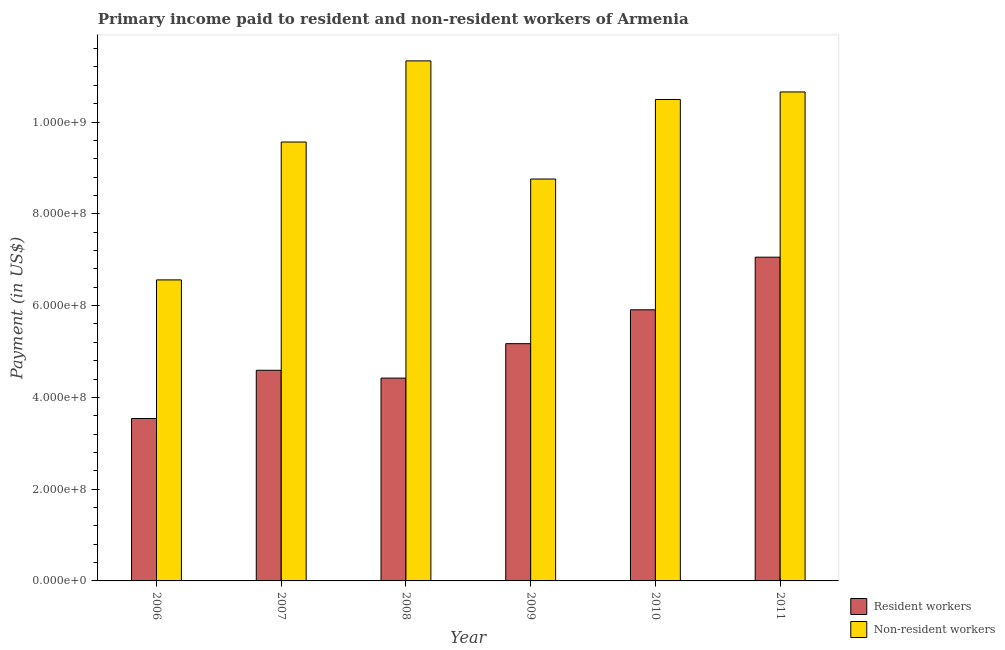How many different coloured bars are there?
Ensure brevity in your answer.  2. Are the number of bars on each tick of the X-axis equal?
Give a very brief answer. Yes. How many bars are there on the 4th tick from the right?
Offer a very short reply. 2. What is the label of the 3rd group of bars from the left?
Offer a very short reply. 2008. In how many cases, is the number of bars for a given year not equal to the number of legend labels?
Provide a succinct answer. 0. What is the payment made to resident workers in 2009?
Your response must be concise. 5.17e+08. Across all years, what is the maximum payment made to non-resident workers?
Your answer should be compact. 1.13e+09. Across all years, what is the minimum payment made to non-resident workers?
Offer a very short reply. 6.56e+08. What is the total payment made to non-resident workers in the graph?
Ensure brevity in your answer.  5.74e+09. What is the difference between the payment made to non-resident workers in 2006 and that in 2009?
Provide a short and direct response. -2.20e+08. What is the difference between the payment made to non-resident workers in 2008 and the payment made to resident workers in 2007?
Your answer should be compact. 1.77e+08. What is the average payment made to non-resident workers per year?
Your answer should be compact. 9.56e+08. In the year 2010, what is the difference between the payment made to resident workers and payment made to non-resident workers?
Make the answer very short. 0. In how many years, is the payment made to non-resident workers greater than 760000000 US$?
Keep it short and to the point. 5. What is the ratio of the payment made to resident workers in 2010 to that in 2011?
Your answer should be compact. 0.84. Is the payment made to resident workers in 2007 less than that in 2009?
Keep it short and to the point. Yes. What is the difference between the highest and the second highest payment made to non-resident workers?
Offer a terse response. 6.77e+07. What is the difference between the highest and the lowest payment made to non-resident workers?
Make the answer very short. 4.77e+08. What does the 2nd bar from the left in 2008 represents?
Keep it short and to the point. Non-resident workers. What does the 1st bar from the right in 2006 represents?
Offer a terse response. Non-resident workers. How many bars are there?
Give a very brief answer. 12. Are all the bars in the graph horizontal?
Offer a terse response. No. How many years are there in the graph?
Offer a terse response. 6. What is the difference between two consecutive major ticks on the Y-axis?
Offer a terse response. 2.00e+08. Are the values on the major ticks of Y-axis written in scientific E-notation?
Provide a succinct answer. Yes. Does the graph contain any zero values?
Your response must be concise. No. Where does the legend appear in the graph?
Your response must be concise. Bottom right. How many legend labels are there?
Keep it short and to the point. 2. How are the legend labels stacked?
Your answer should be very brief. Vertical. What is the title of the graph?
Your response must be concise. Primary income paid to resident and non-resident workers of Armenia. Does "UN agencies" appear as one of the legend labels in the graph?
Offer a terse response. No. What is the label or title of the X-axis?
Offer a terse response. Year. What is the label or title of the Y-axis?
Give a very brief answer. Payment (in US$). What is the Payment (in US$) in Resident workers in 2006?
Offer a very short reply. 3.54e+08. What is the Payment (in US$) in Non-resident workers in 2006?
Offer a terse response. 6.56e+08. What is the Payment (in US$) in Resident workers in 2007?
Keep it short and to the point. 4.59e+08. What is the Payment (in US$) in Non-resident workers in 2007?
Give a very brief answer. 9.56e+08. What is the Payment (in US$) of Resident workers in 2008?
Keep it short and to the point. 4.42e+08. What is the Payment (in US$) of Non-resident workers in 2008?
Make the answer very short. 1.13e+09. What is the Payment (in US$) of Resident workers in 2009?
Offer a terse response. 5.17e+08. What is the Payment (in US$) of Non-resident workers in 2009?
Ensure brevity in your answer.  8.76e+08. What is the Payment (in US$) in Resident workers in 2010?
Keep it short and to the point. 5.91e+08. What is the Payment (in US$) in Non-resident workers in 2010?
Provide a succinct answer. 1.05e+09. What is the Payment (in US$) of Resident workers in 2011?
Offer a very short reply. 7.05e+08. What is the Payment (in US$) of Non-resident workers in 2011?
Your answer should be very brief. 1.07e+09. Across all years, what is the maximum Payment (in US$) of Resident workers?
Your answer should be very brief. 7.05e+08. Across all years, what is the maximum Payment (in US$) in Non-resident workers?
Make the answer very short. 1.13e+09. Across all years, what is the minimum Payment (in US$) of Resident workers?
Your response must be concise. 3.54e+08. Across all years, what is the minimum Payment (in US$) in Non-resident workers?
Your response must be concise. 6.56e+08. What is the total Payment (in US$) in Resident workers in the graph?
Provide a short and direct response. 3.07e+09. What is the total Payment (in US$) of Non-resident workers in the graph?
Ensure brevity in your answer.  5.74e+09. What is the difference between the Payment (in US$) in Resident workers in 2006 and that in 2007?
Your response must be concise. -1.05e+08. What is the difference between the Payment (in US$) in Non-resident workers in 2006 and that in 2007?
Keep it short and to the point. -3.00e+08. What is the difference between the Payment (in US$) in Resident workers in 2006 and that in 2008?
Offer a terse response. -8.80e+07. What is the difference between the Payment (in US$) in Non-resident workers in 2006 and that in 2008?
Keep it short and to the point. -4.77e+08. What is the difference between the Payment (in US$) of Resident workers in 2006 and that in 2009?
Provide a short and direct response. -1.63e+08. What is the difference between the Payment (in US$) of Non-resident workers in 2006 and that in 2009?
Make the answer very short. -2.20e+08. What is the difference between the Payment (in US$) of Resident workers in 2006 and that in 2010?
Keep it short and to the point. -2.37e+08. What is the difference between the Payment (in US$) of Non-resident workers in 2006 and that in 2010?
Give a very brief answer. -3.93e+08. What is the difference between the Payment (in US$) of Resident workers in 2006 and that in 2011?
Give a very brief answer. -3.52e+08. What is the difference between the Payment (in US$) of Non-resident workers in 2006 and that in 2011?
Give a very brief answer. -4.10e+08. What is the difference between the Payment (in US$) in Resident workers in 2007 and that in 2008?
Keep it short and to the point. 1.71e+07. What is the difference between the Payment (in US$) of Non-resident workers in 2007 and that in 2008?
Keep it short and to the point. -1.77e+08. What is the difference between the Payment (in US$) in Resident workers in 2007 and that in 2009?
Provide a succinct answer. -5.80e+07. What is the difference between the Payment (in US$) in Non-resident workers in 2007 and that in 2009?
Your answer should be very brief. 8.07e+07. What is the difference between the Payment (in US$) in Resident workers in 2007 and that in 2010?
Ensure brevity in your answer.  -1.32e+08. What is the difference between the Payment (in US$) in Non-resident workers in 2007 and that in 2010?
Offer a very short reply. -9.26e+07. What is the difference between the Payment (in US$) in Resident workers in 2007 and that in 2011?
Your answer should be compact. -2.46e+08. What is the difference between the Payment (in US$) of Non-resident workers in 2007 and that in 2011?
Keep it short and to the point. -1.09e+08. What is the difference between the Payment (in US$) of Resident workers in 2008 and that in 2009?
Provide a succinct answer. -7.50e+07. What is the difference between the Payment (in US$) in Non-resident workers in 2008 and that in 2009?
Offer a very short reply. 2.57e+08. What is the difference between the Payment (in US$) of Resident workers in 2008 and that in 2010?
Your answer should be compact. -1.49e+08. What is the difference between the Payment (in US$) in Non-resident workers in 2008 and that in 2010?
Your response must be concise. 8.42e+07. What is the difference between the Payment (in US$) in Resident workers in 2008 and that in 2011?
Offer a very short reply. -2.63e+08. What is the difference between the Payment (in US$) in Non-resident workers in 2008 and that in 2011?
Provide a short and direct response. 6.77e+07. What is the difference between the Payment (in US$) of Resident workers in 2009 and that in 2010?
Ensure brevity in your answer.  -7.38e+07. What is the difference between the Payment (in US$) of Non-resident workers in 2009 and that in 2010?
Provide a short and direct response. -1.73e+08. What is the difference between the Payment (in US$) in Resident workers in 2009 and that in 2011?
Your answer should be very brief. -1.88e+08. What is the difference between the Payment (in US$) in Non-resident workers in 2009 and that in 2011?
Give a very brief answer. -1.90e+08. What is the difference between the Payment (in US$) of Resident workers in 2010 and that in 2011?
Your answer should be compact. -1.15e+08. What is the difference between the Payment (in US$) of Non-resident workers in 2010 and that in 2011?
Your answer should be compact. -1.65e+07. What is the difference between the Payment (in US$) of Resident workers in 2006 and the Payment (in US$) of Non-resident workers in 2007?
Keep it short and to the point. -6.03e+08. What is the difference between the Payment (in US$) of Resident workers in 2006 and the Payment (in US$) of Non-resident workers in 2008?
Give a very brief answer. -7.79e+08. What is the difference between the Payment (in US$) of Resident workers in 2006 and the Payment (in US$) of Non-resident workers in 2009?
Your answer should be compact. -5.22e+08. What is the difference between the Payment (in US$) of Resident workers in 2006 and the Payment (in US$) of Non-resident workers in 2010?
Offer a terse response. -6.95e+08. What is the difference between the Payment (in US$) of Resident workers in 2006 and the Payment (in US$) of Non-resident workers in 2011?
Keep it short and to the point. -7.12e+08. What is the difference between the Payment (in US$) in Resident workers in 2007 and the Payment (in US$) in Non-resident workers in 2008?
Offer a terse response. -6.74e+08. What is the difference between the Payment (in US$) in Resident workers in 2007 and the Payment (in US$) in Non-resident workers in 2009?
Give a very brief answer. -4.17e+08. What is the difference between the Payment (in US$) in Resident workers in 2007 and the Payment (in US$) in Non-resident workers in 2010?
Offer a terse response. -5.90e+08. What is the difference between the Payment (in US$) in Resident workers in 2007 and the Payment (in US$) in Non-resident workers in 2011?
Give a very brief answer. -6.07e+08. What is the difference between the Payment (in US$) of Resident workers in 2008 and the Payment (in US$) of Non-resident workers in 2009?
Offer a terse response. -4.34e+08. What is the difference between the Payment (in US$) of Resident workers in 2008 and the Payment (in US$) of Non-resident workers in 2010?
Offer a very short reply. -6.07e+08. What is the difference between the Payment (in US$) of Resident workers in 2008 and the Payment (in US$) of Non-resident workers in 2011?
Your response must be concise. -6.24e+08. What is the difference between the Payment (in US$) of Resident workers in 2009 and the Payment (in US$) of Non-resident workers in 2010?
Your answer should be very brief. -5.32e+08. What is the difference between the Payment (in US$) in Resident workers in 2009 and the Payment (in US$) in Non-resident workers in 2011?
Provide a succinct answer. -5.49e+08. What is the difference between the Payment (in US$) in Resident workers in 2010 and the Payment (in US$) in Non-resident workers in 2011?
Your answer should be compact. -4.75e+08. What is the average Payment (in US$) of Resident workers per year?
Provide a short and direct response. 5.11e+08. What is the average Payment (in US$) of Non-resident workers per year?
Your answer should be compact. 9.56e+08. In the year 2006, what is the difference between the Payment (in US$) in Resident workers and Payment (in US$) in Non-resident workers?
Ensure brevity in your answer.  -3.02e+08. In the year 2007, what is the difference between the Payment (in US$) of Resident workers and Payment (in US$) of Non-resident workers?
Ensure brevity in your answer.  -4.97e+08. In the year 2008, what is the difference between the Payment (in US$) in Resident workers and Payment (in US$) in Non-resident workers?
Your response must be concise. -6.91e+08. In the year 2009, what is the difference between the Payment (in US$) of Resident workers and Payment (in US$) of Non-resident workers?
Ensure brevity in your answer.  -3.59e+08. In the year 2010, what is the difference between the Payment (in US$) in Resident workers and Payment (in US$) in Non-resident workers?
Your answer should be very brief. -4.58e+08. In the year 2011, what is the difference between the Payment (in US$) in Resident workers and Payment (in US$) in Non-resident workers?
Your answer should be compact. -3.60e+08. What is the ratio of the Payment (in US$) in Resident workers in 2006 to that in 2007?
Offer a very short reply. 0.77. What is the ratio of the Payment (in US$) of Non-resident workers in 2006 to that in 2007?
Offer a terse response. 0.69. What is the ratio of the Payment (in US$) in Resident workers in 2006 to that in 2008?
Provide a succinct answer. 0.8. What is the ratio of the Payment (in US$) of Non-resident workers in 2006 to that in 2008?
Your answer should be very brief. 0.58. What is the ratio of the Payment (in US$) of Resident workers in 2006 to that in 2009?
Your answer should be very brief. 0.68. What is the ratio of the Payment (in US$) in Non-resident workers in 2006 to that in 2009?
Provide a succinct answer. 0.75. What is the ratio of the Payment (in US$) of Resident workers in 2006 to that in 2010?
Make the answer very short. 0.6. What is the ratio of the Payment (in US$) of Non-resident workers in 2006 to that in 2010?
Your response must be concise. 0.63. What is the ratio of the Payment (in US$) of Resident workers in 2006 to that in 2011?
Your response must be concise. 0.5. What is the ratio of the Payment (in US$) of Non-resident workers in 2006 to that in 2011?
Your answer should be compact. 0.62. What is the ratio of the Payment (in US$) of Resident workers in 2007 to that in 2008?
Provide a succinct answer. 1.04. What is the ratio of the Payment (in US$) of Non-resident workers in 2007 to that in 2008?
Ensure brevity in your answer.  0.84. What is the ratio of the Payment (in US$) of Resident workers in 2007 to that in 2009?
Offer a very short reply. 0.89. What is the ratio of the Payment (in US$) of Non-resident workers in 2007 to that in 2009?
Your answer should be very brief. 1.09. What is the ratio of the Payment (in US$) in Resident workers in 2007 to that in 2010?
Provide a succinct answer. 0.78. What is the ratio of the Payment (in US$) in Non-resident workers in 2007 to that in 2010?
Your answer should be compact. 0.91. What is the ratio of the Payment (in US$) of Resident workers in 2007 to that in 2011?
Make the answer very short. 0.65. What is the ratio of the Payment (in US$) of Non-resident workers in 2007 to that in 2011?
Keep it short and to the point. 0.9. What is the ratio of the Payment (in US$) in Resident workers in 2008 to that in 2009?
Keep it short and to the point. 0.85. What is the ratio of the Payment (in US$) of Non-resident workers in 2008 to that in 2009?
Keep it short and to the point. 1.29. What is the ratio of the Payment (in US$) in Resident workers in 2008 to that in 2010?
Offer a terse response. 0.75. What is the ratio of the Payment (in US$) of Non-resident workers in 2008 to that in 2010?
Provide a short and direct response. 1.08. What is the ratio of the Payment (in US$) in Resident workers in 2008 to that in 2011?
Offer a terse response. 0.63. What is the ratio of the Payment (in US$) in Non-resident workers in 2008 to that in 2011?
Provide a short and direct response. 1.06. What is the ratio of the Payment (in US$) in Resident workers in 2009 to that in 2010?
Provide a short and direct response. 0.88. What is the ratio of the Payment (in US$) of Non-resident workers in 2009 to that in 2010?
Ensure brevity in your answer.  0.83. What is the ratio of the Payment (in US$) of Resident workers in 2009 to that in 2011?
Give a very brief answer. 0.73. What is the ratio of the Payment (in US$) of Non-resident workers in 2009 to that in 2011?
Offer a very short reply. 0.82. What is the ratio of the Payment (in US$) of Resident workers in 2010 to that in 2011?
Your answer should be very brief. 0.84. What is the ratio of the Payment (in US$) of Non-resident workers in 2010 to that in 2011?
Ensure brevity in your answer.  0.98. What is the difference between the highest and the second highest Payment (in US$) of Resident workers?
Provide a succinct answer. 1.15e+08. What is the difference between the highest and the second highest Payment (in US$) in Non-resident workers?
Give a very brief answer. 6.77e+07. What is the difference between the highest and the lowest Payment (in US$) in Resident workers?
Keep it short and to the point. 3.52e+08. What is the difference between the highest and the lowest Payment (in US$) of Non-resident workers?
Your answer should be compact. 4.77e+08. 